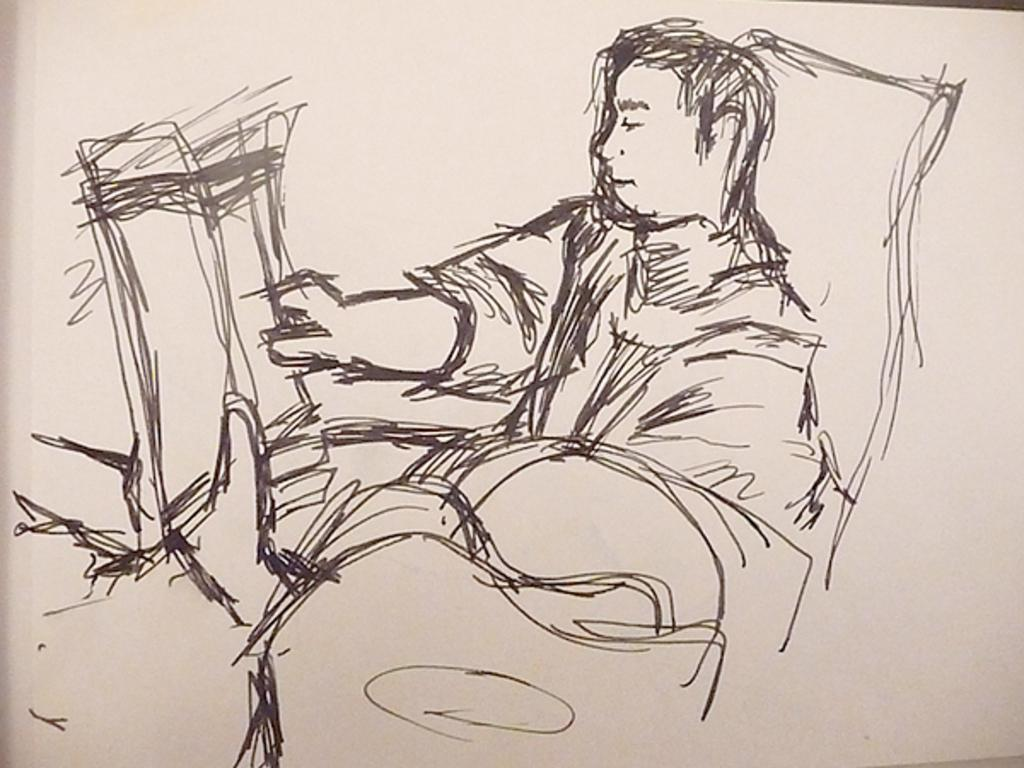What type of image is shown in the picture? The image is a picture of a drawing. What is the main subject of the drawing? There is a person depicted in the drawing. What type of card is being used to draw the person in the image? There is no reference to a card being used to draw the person in the image. What type of beef is being cooked in the background of the image? There is no beef or cooking activity present in the image. 